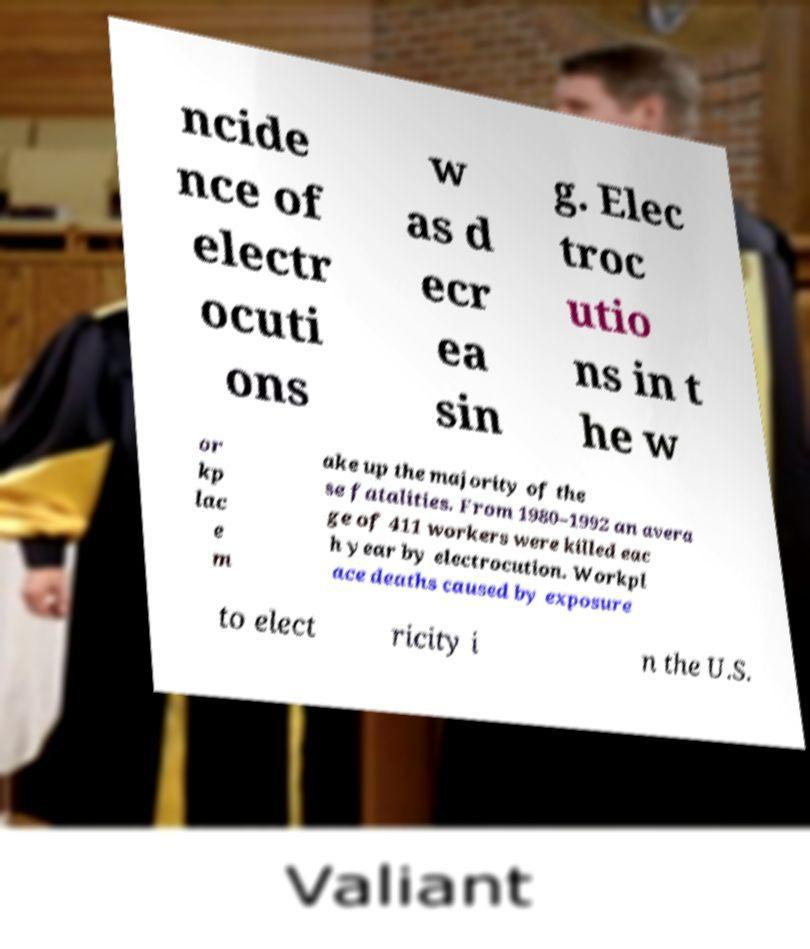Can you accurately transcribe the text from the provided image for me? ncide nce of electr ocuti ons w as d ecr ea sin g. Elec troc utio ns in t he w or kp lac e m ake up the majority of the se fatalities. From 1980–1992 an avera ge of 411 workers were killed eac h year by electrocution. Workpl ace deaths caused by exposure to elect ricity i n the U.S. 